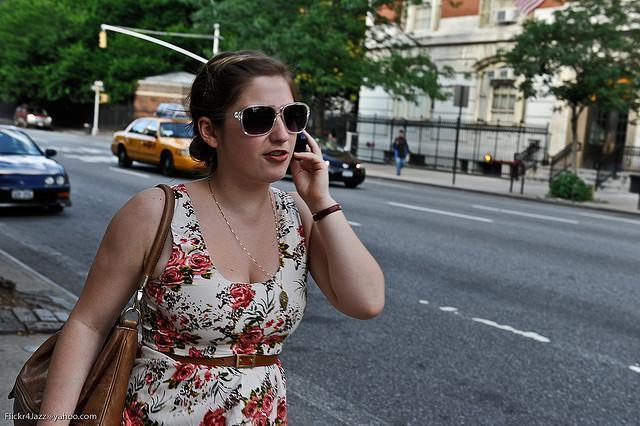What is the woman wearing sunglasses doing?
Select the accurate answer and provide explanation: 'Answer: answer
Rationale: rationale.'
Options: Crossing street, talking, listening, recording. Answer: talking.
Rationale: She is talking on a phone. 